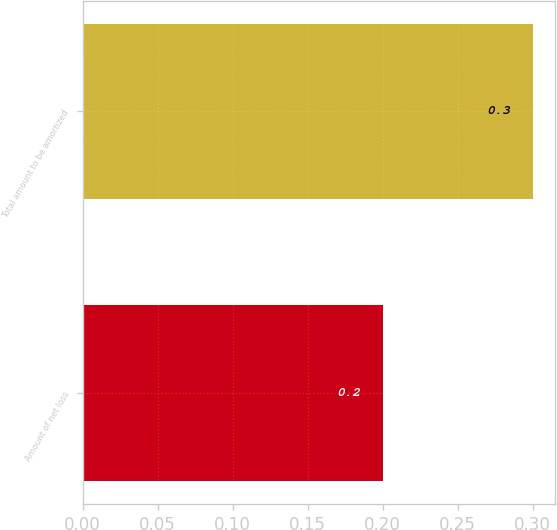<chart> <loc_0><loc_0><loc_500><loc_500><bar_chart><fcel>Amount of net loss<fcel>Total amount to be amortized<nl><fcel>0.2<fcel>0.3<nl></chart> 